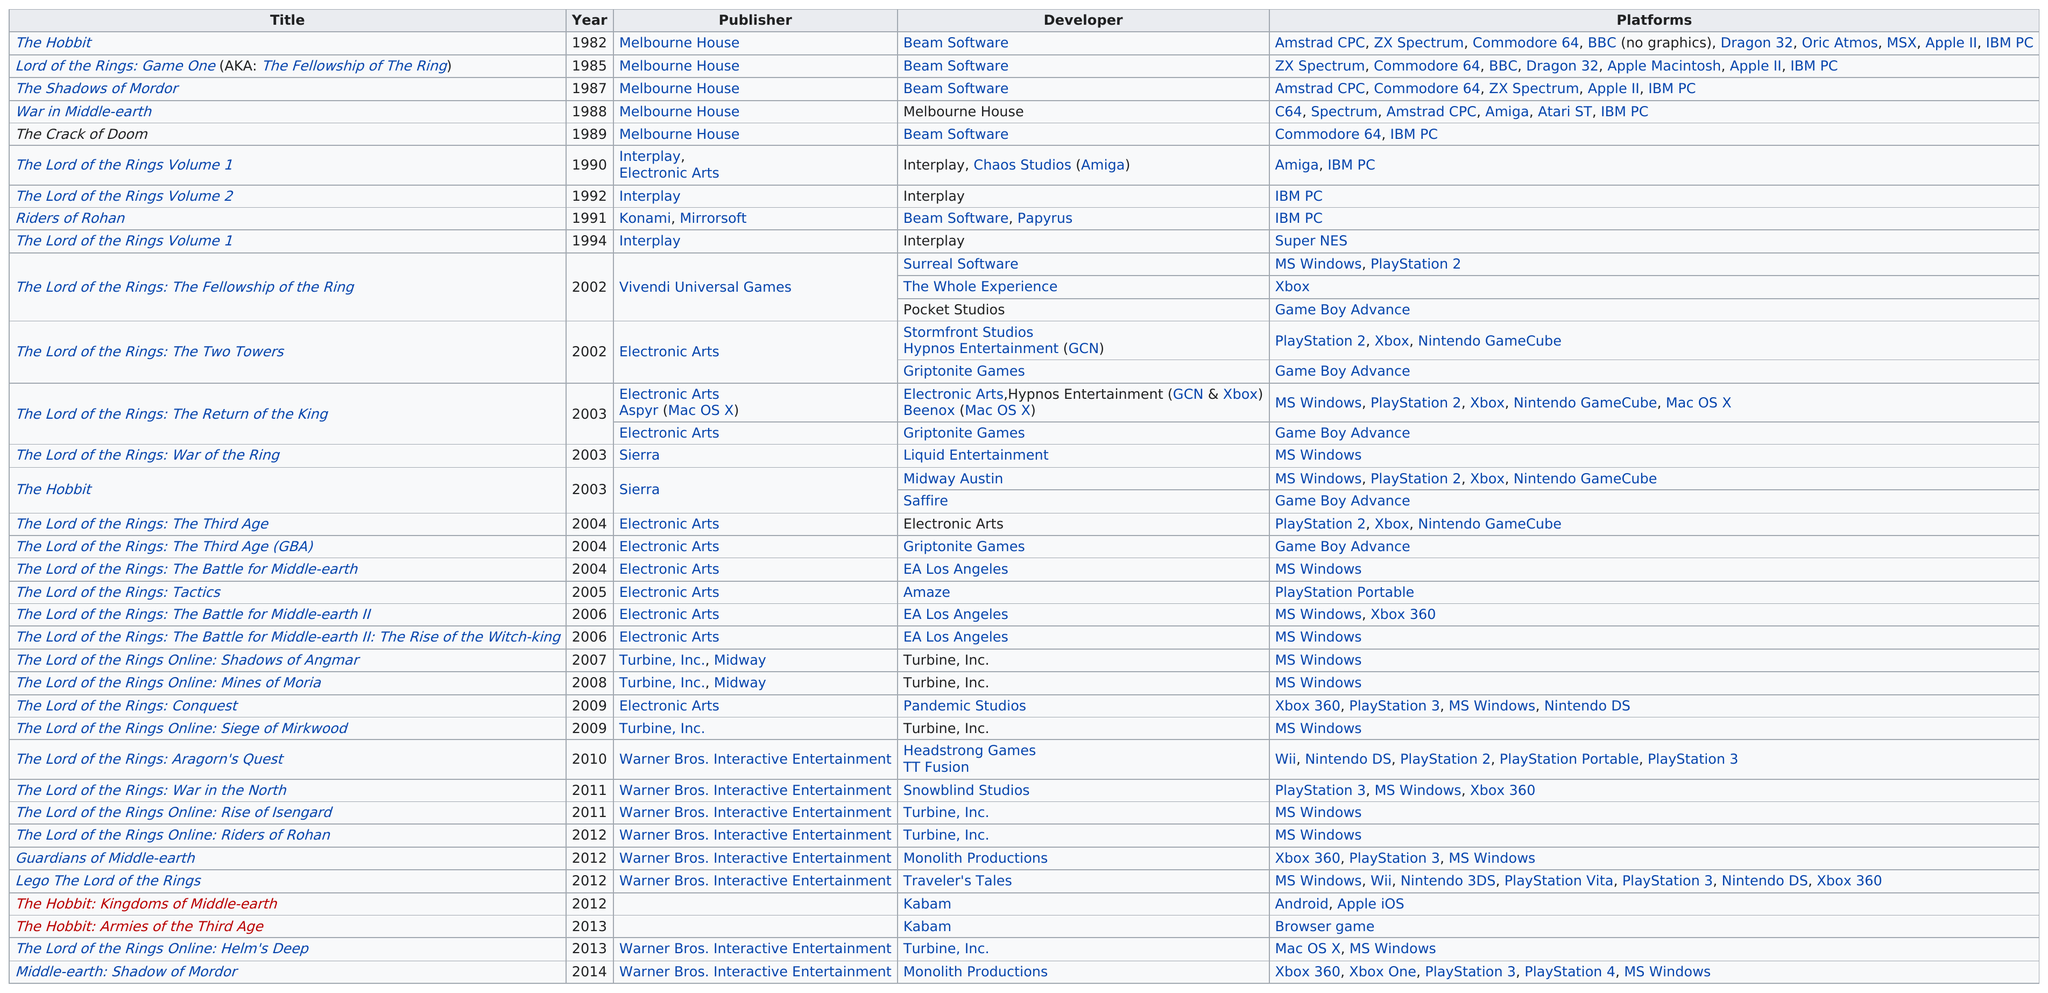Specify some key components in this picture. Melbourne House was the publisher who worked on a title consecutively from 1982 to 1989. The Hobbit project had the greatest number of platforms. One title not developed by Melbourne House is 'The Lord of the Rings Volume 1.' There have been nine official Middle-earth video games prior to 2000. Electronic Arts was the publisher with the most projects. 